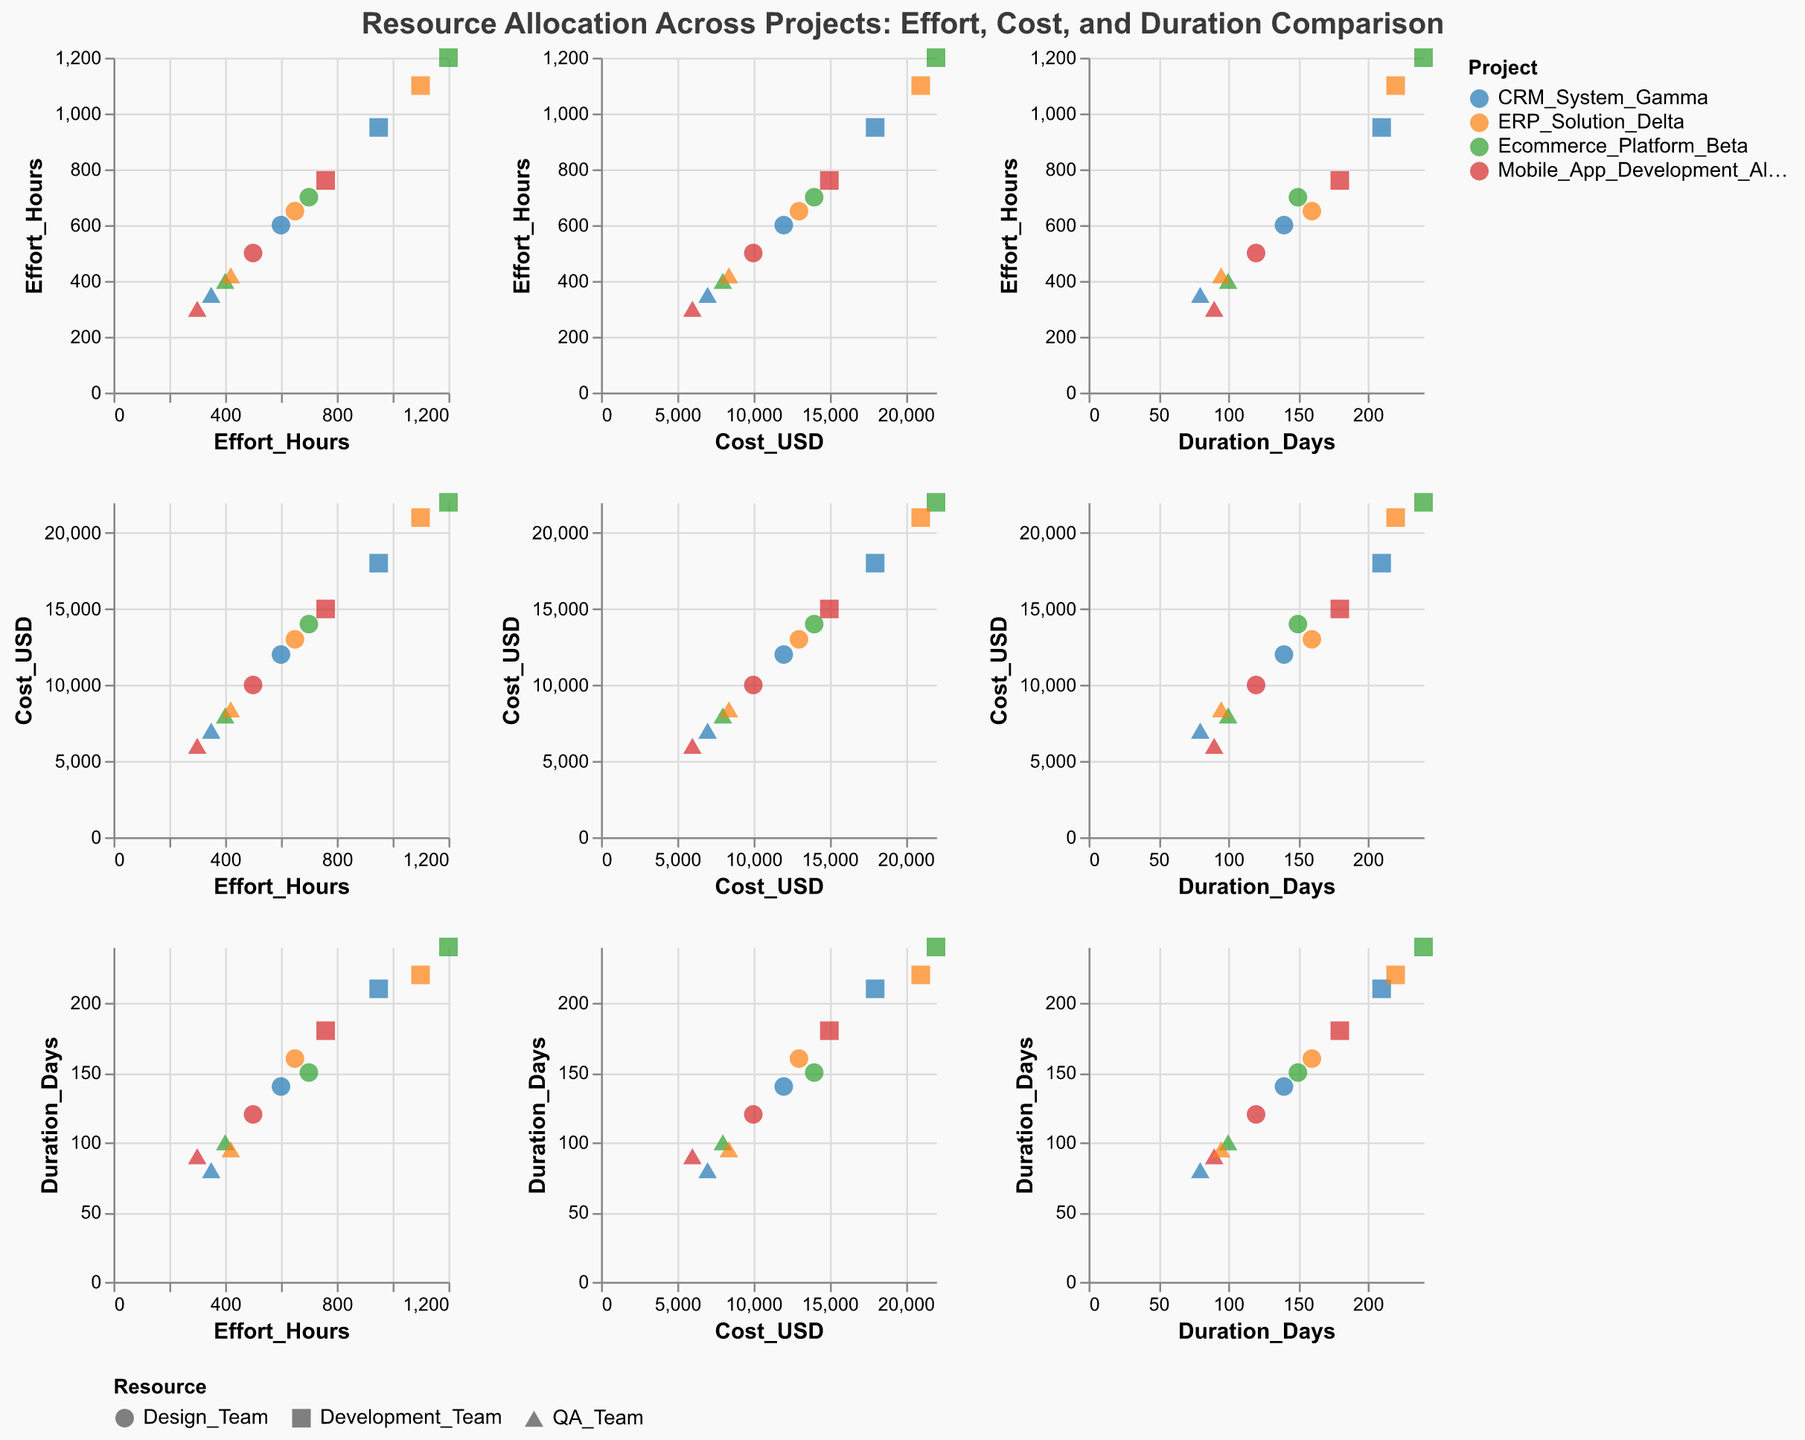what are the axes labels? The axes labels of the figure are "Effort_Hours" for the x-axis and "Cost_USD" for the y-axis. This information can be seen in the labels on the scatter plot matrix.
Answer: Effort_Hours and Cost_USD How many data points are from the project "CRM_System_Gamma"? By looking at the colors and the legend, we count the occurrences of the "CRM_System_Gamma" color in the scatter plot, which corresponds to three data points: Development_Team, QA_Team, and Design_Team.
Answer: Three Which resource achieved the highest effort_hours across all projects? By scanning all the points in the Effort_Hours column, we find that the point with the highest value (1200) belongs to the Development_Team in the Ecommerce_Platform_Beta project.
Answer: Development_Team What is the relationship between the duration and cost for "ERP_Solution_Delta"? By locating the points specific to "ERP_Solution_Delta" and considering their positions in the Duration_Days vs. Cost_USD pairing, we observe that higher duration values correspond to higher costs.
Answer: Positive relationship How does the average cost of QA_Teams compare to that of Design_Teams across all projects? Sum the costs for all QA_Teams and Design_Teams, then divide by the number of instances (QA_Team: 6000+8000+7000+8400=29400, 4 instances; Design_Team: 10000+14000+12000+13000=49000, 4 instances). Average QA: 29400/4=7350 vs. Design: 49000/4=12250.
Answer: QA_Team: 7350, Design_Team: 12250 Which project has the most balanced resource allocation in terms of effort and cost? Each project's points should lie as close as possible to a straight line if well balanced. Mobile_App_Development_Alpha appears balanced because the costs and efforts of its resource teams are not skewed largely in any direction.
Answer: Mobile_App_Development_Alpha 